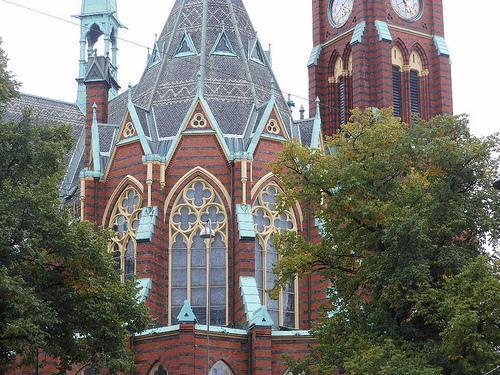How many clocks are there?
Give a very brief answer. 2. 